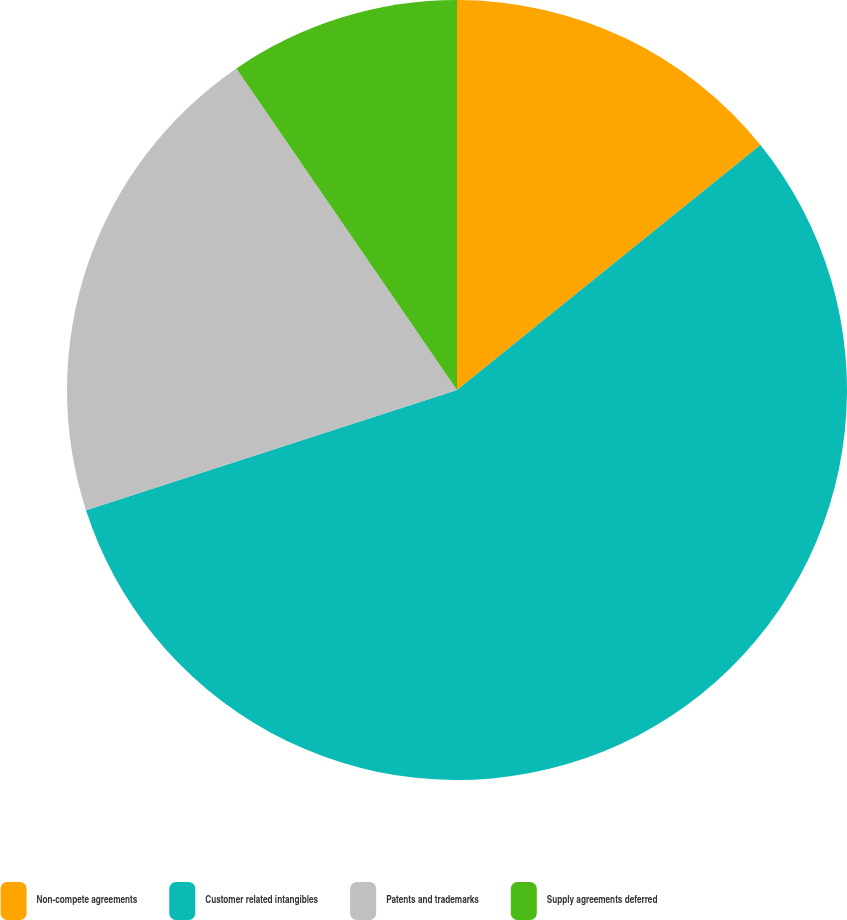Convert chart to OTSL. <chart><loc_0><loc_0><loc_500><loc_500><pie_chart><fcel>Non-compete agreements<fcel>Customer related intangibles<fcel>Patents and trademarks<fcel>Supply agreements deferred<nl><fcel>14.19%<fcel>55.82%<fcel>20.42%<fcel>9.57%<nl></chart> 